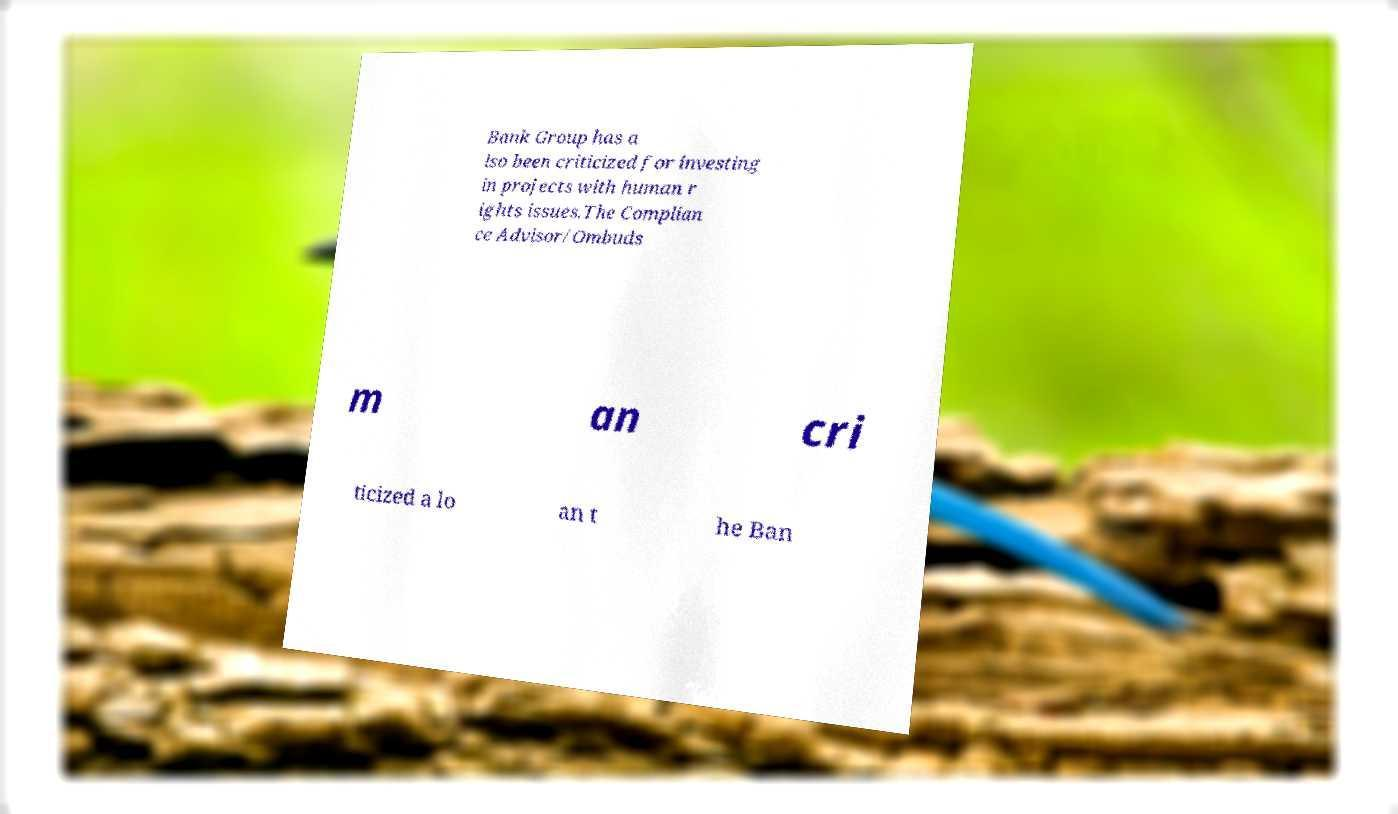Can you accurately transcribe the text from the provided image for me? Bank Group has a lso been criticized for investing in projects with human r ights issues.The Complian ce Advisor/Ombuds m an cri ticized a lo an t he Ban 